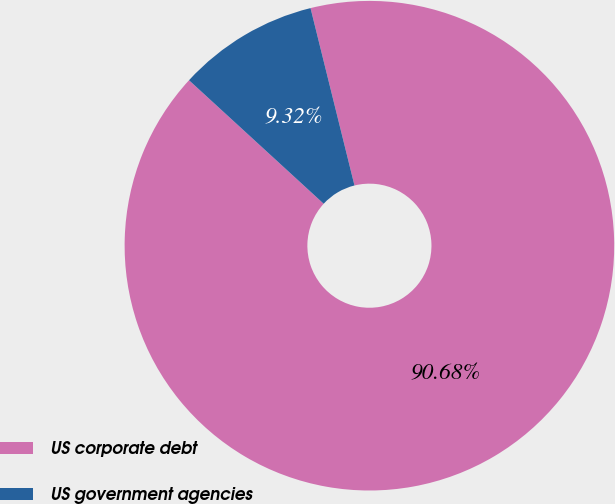<chart> <loc_0><loc_0><loc_500><loc_500><pie_chart><fcel>US corporate debt<fcel>US government agencies<nl><fcel>90.68%<fcel>9.32%<nl></chart> 